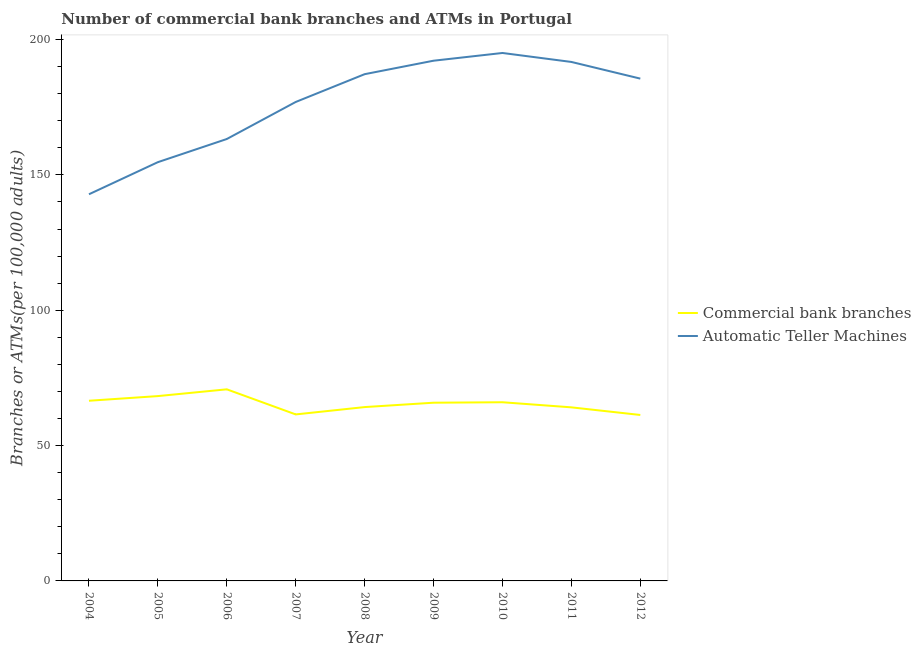Does the line corresponding to number of commercal bank branches intersect with the line corresponding to number of atms?
Ensure brevity in your answer.  No. Is the number of lines equal to the number of legend labels?
Offer a terse response. Yes. What is the number of atms in 2009?
Your answer should be very brief. 192.19. Across all years, what is the maximum number of atms?
Give a very brief answer. 195.04. Across all years, what is the minimum number of atms?
Provide a short and direct response. 142.84. What is the total number of atms in the graph?
Offer a very short reply. 1589.49. What is the difference between the number of commercal bank branches in 2005 and that in 2010?
Ensure brevity in your answer.  2.27. What is the difference between the number of atms in 2008 and the number of commercal bank branches in 2007?
Provide a succinct answer. 125.7. What is the average number of commercal bank branches per year?
Your answer should be very brief. 65.41. In the year 2011, what is the difference between the number of commercal bank branches and number of atms?
Your answer should be very brief. -127.6. In how many years, is the number of commercal bank branches greater than 130?
Make the answer very short. 0. What is the ratio of the number of atms in 2005 to that in 2006?
Make the answer very short. 0.95. What is the difference between the highest and the second highest number of commercal bank branches?
Make the answer very short. 2.5. What is the difference between the highest and the lowest number of commercal bank branches?
Keep it short and to the point. 9.48. In how many years, is the number of atms greater than the average number of atms taken over all years?
Provide a short and direct response. 6. Does the number of commercal bank branches monotonically increase over the years?
Keep it short and to the point. No. Is the number of atms strictly less than the number of commercal bank branches over the years?
Your answer should be compact. No. How many years are there in the graph?
Provide a succinct answer. 9. Are the values on the major ticks of Y-axis written in scientific E-notation?
Make the answer very short. No. Does the graph contain any zero values?
Provide a short and direct response. No. Does the graph contain grids?
Provide a succinct answer. No. Where does the legend appear in the graph?
Give a very brief answer. Center right. How many legend labels are there?
Provide a short and direct response. 2. What is the title of the graph?
Ensure brevity in your answer.  Number of commercial bank branches and ATMs in Portugal. Does "Lower secondary rate" appear as one of the legend labels in the graph?
Your response must be concise. No. What is the label or title of the Y-axis?
Ensure brevity in your answer.  Branches or ATMs(per 100,0 adults). What is the Branches or ATMs(per 100,000 adults) in Commercial bank branches in 2004?
Ensure brevity in your answer.  66.56. What is the Branches or ATMs(per 100,000 adults) in Automatic Teller Machines in 2004?
Your response must be concise. 142.84. What is the Branches or ATMs(per 100,000 adults) of Commercial bank branches in 2005?
Your answer should be very brief. 68.28. What is the Branches or ATMs(per 100,000 adults) of Automatic Teller Machines in 2005?
Give a very brief answer. 154.71. What is the Branches or ATMs(per 100,000 adults) in Commercial bank branches in 2006?
Keep it short and to the point. 70.78. What is the Branches or ATMs(per 100,000 adults) of Automatic Teller Machines in 2006?
Make the answer very short. 163.26. What is the Branches or ATMs(per 100,000 adults) in Commercial bank branches in 2007?
Give a very brief answer. 61.51. What is the Branches or ATMs(per 100,000 adults) of Automatic Teller Machines in 2007?
Make the answer very short. 176.94. What is the Branches or ATMs(per 100,000 adults) of Commercial bank branches in 2008?
Keep it short and to the point. 64.22. What is the Branches or ATMs(per 100,000 adults) of Automatic Teller Machines in 2008?
Keep it short and to the point. 187.21. What is the Branches or ATMs(per 100,000 adults) in Commercial bank branches in 2009?
Provide a short and direct response. 65.84. What is the Branches or ATMs(per 100,000 adults) of Automatic Teller Machines in 2009?
Your answer should be compact. 192.19. What is the Branches or ATMs(per 100,000 adults) of Commercial bank branches in 2010?
Provide a succinct answer. 66.01. What is the Branches or ATMs(per 100,000 adults) in Automatic Teller Machines in 2010?
Your answer should be compact. 195.04. What is the Branches or ATMs(per 100,000 adults) of Commercial bank branches in 2011?
Ensure brevity in your answer.  64.13. What is the Branches or ATMs(per 100,000 adults) in Automatic Teller Machines in 2011?
Your answer should be very brief. 191.73. What is the Branches or ATMs(per 100,000 adults) in Commercial bank branches in 2012?
Offer a very short reply. 61.31. What is the Branches or ATMs(per 100,000 adults) of Automatic Teller Machines in 2012?
Your answer should be compact. 185.57. Across all years, what is the maximum Branches or ATMs(per 100,000 adults) in Commercial bank branches?
Provide a short and direct response. 70.78. Across all years, what is the maximum Branches or ATMs(per 100,000 adults) in Automatic Teller Machines?
Give a very brief answer. 195.04. Across all years, what is the minimum Branches or ATMs(per 100,000 adults) in Commercial bank branches?
Give a very brief answer. 61.31. Across all years, what is the minimum Branches or ATMs(per 100,000 adults) in Automatic Teller Machines?
Offer a terse response. 142.84. What is the total Branches or ATMs(per 100,000 adults) of Commercial bank branches in the graph?
Keep it short and to the point. 588.65. What is the total Branches or ATMs(per 100,000 adults) of Automatic Teller Machines in the graph?
Ensure brevity in your answer.  1589.49. What is the difference between the Branches or ATMs(per 100,000 adults) in Commercial bank branches in 2004 and that in 2005?
Your answer should be compact. -1.72. What is the difference between the Branches or ATMs(per 100,000 adults) of Automatic Teller Machines in 2004 and that in 2005?
Keep it short and to the point. -11.86. What is the difference between the Branches or ATMs(per 100,000 adults) in Commercial bank branches in 2004 and that in 2006?
Ensure brevity in your answer.  -4.22. What is the difference between the Branches or ATMs(per 100,000 adults) in Automatic Teller Machines in 2004 and that in 2006?
Offer a very short reply. -20.42. What is the difference between the Branches or ATMs(per 100,000 adults) in Commercial bank branches in 2004 and that in 2007?
Offer a very short reply. 5.05. What is the difference between the Branches or ATMs(per 100,000 adults) of Automatic Teller Machines in 2004 and that in 2007?
Give a very brief answer. -34.1. What is the difference between the Branches or ATMs(per 100,000 adults) in Commercial bank branches in 2004 and that in 2008?
Your answer should be compact. 2.34. What is the difference between the Branches or ATMs(per 100,000 adults) of Automatic Teller Machines in 2004 and that in 2008?
Your answer should be very brief. -44.37. What is the difference between the Branches or ATMs(per 100,000 adults) of Commercial bank branches in 2004 and that in 2009?
Ensure brevity in your answer.  0.72. What is the difference between the Branches or ATMs(per 100,000 adults) in Automatic Teller Machines in 2004 and that in 2009?
Provide a succinct answer. -49.34. What is the difference between the Branches or ATMs(per 100,000 adults) of Commercial bank branches in 2004 and that in 2010?
Provide a short and direct response. 0.55. What is the difference between the Branches or ATMs(per 100,000 adults) in Automatic Teller Machines in 2004 and that in 2010?
Your response must be concise. -52.2. What is the difference between the Branches or ATMs(per 100,000 adults) in Commercial bank branches in 2004 and that in 2011?
Keep it short and to the point. 2.44. What is the difference between the Branches or ATMs(per 100,000 adults) of Automatic Teller Machines in 2004 and that in 2011?
Your answer should be compact. -48.89. What is the difference between the Branches or ATMs(per 100,000 adults) in Commercial bank branches in 2004 and that in 2012?
Your answer should be very brief. 5.25. What is the difference between the Branches or ATMs(per 100,000 adults) of Automatic Teller Machines in 2004 and that in 2012?
Provide a succinct answer. -42.73. What is the difference between the Branches or ATMs(per 100,000 adults) in Commercial bank branches in 2005 and that in 2006?
Ensure brevity in your answer.  -2.5. What is the difference between the Branches or ATMs(per 100,000 adults) of Automatic Teller Machines in 2005 and that in 2006?
Make the answer very short. -8.55. What is the difference between the Branches or ATMs(per 100,000 adults) in Commercial bank branches in 2005 and that in 2007?
Keep it short and to the point. 6.77. What is the difference between the Branches or ATMs(per 100,000 adults) of Automatic Teller Machines in 2005 and that in 2007?
Provide a succinct answer. -22.23. What is the difference between the Branches or ATMs(per 100,000 adults) of Commercial bank branches in 2005 and that in 2008?
Make the answer very short. 4.06. What is the difference between the Branches or ATMs(per 100,000 adults) in Automatic Teller Machines in 2005 and that in 2008?
Offer a very short reply. -32.5. What is the difference between the Branches or ATMs(per 100,000 adults) in Commercial bank branches in 2005 and that in 2009?
Provide a succinct answer. 2.44. What is the difference between the Branches or ATMs(per 100,000 adults) of Automatic Teller Machines in 2005 and that in 2009?
Offer a very short reply. -37.48. What is the difference between the Branches or ATMs(per 100,000 adults) in Commercial bank branches in 2005 and that in 2010?
Your answer should be compact. 2.27. What is the difference between the Branches or ATMs(per 100,000 adults) of Automatic Teller Machines in 2005 and that in 2010?
Your answer should be compact. -40.34. What is the difference between the Branches or ATMs(per 100,000 adults) of Commercial bank branches in 2005 and that in 2011?
Provide a succinct answer. 4.16. What is the difference between the Branches or ATMs(per 100,000 adults) in Automatic Teller Machines in 2005 and that in 2011?
Offer a terse response. -37.02. What is the difference between the Branches or ATMs(per 100,000 adults) of Commercial bank branches in 2005 and that in 2012?
Your answer should be very brief. 6.97. What is the difference between the Branches or ATMs(per 100,000 adults) of Automatic Teller Machines in 2005 and that in 2012?
Offer a very short reply. -30.86. What is the difference between the Branches or ATMs(per 100,000 adults) of Commercial bank branches in 2006 and that in 2007?
Ensure brevity in your answer.  9.27. What is the difference between the Branches or ATMs(per 100,000 adults) of Automatic Teller Machines in 2006 and that in 2007?
Keep it short and to the point. -13.68. What is the difference between the Branches or ATMs(per 100,000 adults) in Commercial bank branches in 2006 and that in 2008?
Your answer should be compact. 6.56. What is the difference between the Branches or ATMs(per 100,000 adults) in Automatic Teller Machines in 2006 and that in 2008?
Give a very brief answer. -23.95. What is the difference between the Branches or ATMs(per 100,000 adults) of Commercial bank branches in 2006 and that in 2009?
Provide a short and direct response. 4.94. What is the difference between the Branches or ATMs(per 100,000 adults) of Automatic Teller Machines in 2006 and that in 2009?
Give a very brief answer. -28.93. What is the difference between the Branches or ATMs(per 100,000 adults) of Commercial bank branches in 2006 and that in 2010?
Offer a terse response. 4.77. What is the difference between the Branches or ATMs(per 100,000 adults) of Automatic Teller Machines in 2006 and that in 2010?
Ensure brevity in your answer.  -31.78. What is the difference between the Branches or ATMs(per 100,000 adults) of Commercial bank branches in 2006 and that in 2011?
Provide a succinct answer. 6.66. What is the difference between the Branches or ATMs(per 100,000 adults) of Automatic Teller Machines in 2006 and that in 2011?
Make the answer very short. -28.47. What is the difference between the Branches or ATMs(per 100,000 adults) of Commercial bank branches in 2006 and that in 2012?
Keep it short and to the point. 9.48. What is the difference between the Branches or ATMs(per 100,000 adults) in Automatic Teller Machines in 2006 and that in 2012?
Offer a terse response. -22.31. What is the difference between the Branches or ATMs(per 100,000 adults) in Commercial bank branches in 2007 and that in 2008?
Ensure brevity in your answer.  -2.71. What is the difference between the Branches or ATMs(per 100,000 adults) in Automatic Teller Machines in 2007 and that in 2008?
Offer a terse response. -10.27. What is the difference between the Branches or ATMs(per 100,000 adults) in Commercial bank branches in 2007 and that in 2009?
Provide a short and direct response. -4.33. What is the difference between the Branches or ATMs(per 100,000 adults) of Automatic Teller Machines in 2007 and that in 2009?
Your answer should be compact. -15.24. What is the difference between the Branches or ATMs(per 100,000 adults) in Commercial bank branches in 2007 and that in 2010?
Ensure brevity in your answer.  -4.5. What is the difference between the Branches or ATMs(per 100,000 adults) of Automatic Teller Machines in 2007 and that in 2010?
Offer a very short reply. -18.1. What is the difference between the Branches or ATMs(per 100,000 adults) in Commercial bank branches in 2007 and that in 2011?
Give a very brief answer. -2.61. What is the difference between the Branches or ATMs(per 100,000 adults) of Automatic Teller Machines in 2007 and that in 2011?
Your answer should be compact. -14.79. What is the difference between the Branches or ATMs(per 100,000 adults) in Commercial bank branches in 2007 and that in 2012?
Ensure brevity in your answer.  0.2. What is the difference between the Branches or ATMs(per 100,000 adults) in Automatic Teller Machines in 2007 and that in 2012?
Provide a succinct answer. -8.63. What is the difference between the Branches or ATMs(per 100,000 adults) in Commercial bank branches in 2008 and that in 2009?
Your answer should be compact. -1.62. What is the difference between the Branches or ATMs(per 100,000 adults) of Automatic Teller Machines in 2008 and that in 2009?
Provide a short and direct response. -4.98. What is the difference between the Branches or ATMs(per 100,000 adults) of Commercial bank branches in 2008 and that in 2010?
Keep it short and to the point. -1.79. What is the difference between the Branches or ATMs(per 100,000 adults) in Automatic Teller Machines in 2008 and that in 2010?
Provide a succinct answer. -7.83. What is the difference between the Branches or ATMs(per 100,000 adults) of Commercial bank branches in 2008 and that in 2011?
Ensure brevity in your answer.  0.1. What is the difference between the Branches or ATMs(per 100,000 adults) in Automatic Teller Machines in 2008 and that in 2011?
Provide a short and direct response. -4.52. What is the difference between the Branches or ATMs(per 100,000 adults) in Commercial bank branches in 2008 and that in 2012?
Give a very brief answer. 2.91. What is the difference between the Branches or ATMs(per 100,000 adults) of Automatic Teller Machines in 2008 and that in 2012?
Give a very brief answer. 1.64. What is the difference between the Branches or ATMs(per 100,000 adults) in Commercial bank branches in 2009 and that in 2010?
Offer a terse response. -0.17. What is the difference between the Branches or ATMs(per 100,000 adults) of Automatic Teller Machines in 2009 and that in 2010?
Provide a short and direct response. -2.86. What is the difference between the Branches or ATMs(per 100,000 adults) in Commercial bank branches in 2009 and that in 2011?
Offer a terse response. 1.72. What is the difference between the Branches or ATMs(per 100,000 adults) in Automatic Teller Machines in 2009 and that in 2011?
Your answer should be very brief. 0.46. What is the difference between the Branches or ATMs(per 100,000 adults) in Commercial bank branches in 2009 and that in 2012?
Your answer should be compact. 4.53. What is the difference between the Branches or ATMs(per 100,000 adults) in Automatic Teller Machines in 2009 and that in 2012?
Make the answer very short. 6.62. What is the difference between the Branches or ATMs(per 100,000 adults) of Commercial bank branches in 2010 and that in 2011?
Make the answer very short. 1.88. What is the difference between the Branches or ATMs(per 100,000 adults) of Automatic Teller Machines in 2010 and that in 2011?
Ensure brevity in your answer.  3.31. What is the difference between the Branches or ATMs(per 100,000 adults) in Commercial bank branches in 2010 and that in 2012?
Offer a very short reply. 4.7. What is the difference between the Branches or ATMs(per 100,000 adults) in Automatic Teller Machines in 2010 and that in 2012?
Your response must be concise. 9.47. What is the difference between the Branches or ATMs(per 100,000 adults) in Commercial bank branches in 2011 and that in 2012?
Your response must be concise. 2.82. What is the difference between the Branches or ATMs(per 100,000 adults) of Automatic Teller Machines in 2011 and that in 2012?
Provide a succinct answer. 6.16. What is the difference between the Branches or ATMs(per 100,000 adults) of Commercial bank branches in 2004 and the Branches or ATMs(per 100,000 adults) of Automatic Teller Machines in 2005?
Give a very brief answer. -88.15. What is the difference between the Branches or ATMs(per 100,000 adults) in Commercial bank branches in 2004 and the Branches or ATMs(per 100,000 adults) in Automatic Teller Machines in 2006?
Your answer should be compact. -96.7. What is the difference between the Branches or ATMs(per 100,000 adults) in Commercial bank branches in 2004 and the Branches or ATMs(per 100,000 adults) in Automatic Teller Machines in 2007?
Your response must be concise. -110.38. What is the difference between the Branches or ATMs(per 100,000 adults) of Commercial bank branches in 2004 and the Branches or ATMs(per 100,000 adults) of Automatic Teller Machines in 2008?
Give a very brief answer. -120.65. What is the difference between the Branches or ATMs(per 100,000 adults) in Commercial bank branches in 2004 and the Branches or ATMs(per 100,000 adults) in Automatic Teller Machines in 2009?
Provide a succinct answer. -125.62. What is the difference between the Branches or ATMs(per 100,000 adults) of Commercial bank branches in 2004 and the Branches or ATMs(per 100,000 adults) of Automatic Teller Machines in 2010?
Your response must be concise. -128.48. What is the difference between the Branches or ATMs(per 100,000 adults) of Commercial bank branches in 2004 and the Branches or ATMs(per 100,000 adults) of Automatic Teller Machines in 2011?
Offer a terse response. -125.17. What is the difference between the Branches or ATMs(per 100,000 adults) of Commercial bank branches in 2004 and the Branches or ATMs(per 100,000 adults) of Automatic Teller Machines in 2012?
Make the answer very short. -119.01. What is the difference between the Branches or ATMs(per 100,000 adults) in Commercial bank branches in 2005 and the Branches or ATMs(per 100,000 adults) in Automatic Teller Machines in 2006?
Your response must be concise. -94.97. What is the difference between the Branches or ATMs(per 100,000 adults) of Commercial bank branches in 2005 and the Branches or ATMs(per 100,000 adults) of Automatic Teller Machines in 2007?
Provide a succinct answer. -108.66. What is the difference between the Branches or ATMs(per 100,000 adults) in Commercial bank branches in 2005 and the Branches or ATMs(per 100,000 adults) in Automatic Teller Machines in 2008?
Keep it short and to the point. -118.93. What is the difference between the Branches or ATMs(per 100,000 adults) in Commercial bank branches in 2005 and the Branches or ATMs(per 100,000 adults) in Automatic Teller Machines in 2009?
Provide a short and direct response. -123.9. What is the difference between the Branches or ATMs(per 100,000 adults) of Commercial bank branches in 2005 and the Branches or ATMs(per 100,000 adults) of Automatic Teller Machines in 2010?
Make the answer very short. -126.76. What is the difference between the Branches or ATMs(per 100,000 adults) of Commercial bank branches in 2005 and the Branches or ATMs(per 100,000 adults) of Automatic Teller Machines in 2011?
Your answer should be compact. -123.44. What is the difference between the Branches or ATMs(per 100,000 adults) of Commercial bank branches in 2005 and the Branches or ATMs(per 100,000 adults) of Automatic Teller Machines in 2012?
Your answer should be very brief. -117.29. What is the difference between the Branches or ATMs(per 100,000 adults) in Commercial bank branches in 2006 and the Branches or ATMs(per 100,000 adults) in Automatic Teller Machines in 2007?
Offer a terse response. -106.16. What is the difference between the Branches or ATMs(per 100,000 adults) of Commercial bank branches in 2006 and the Branches or ATMs(per 100,000 adults) of Automatic Teller Machines in 2008?
Provide a succinct answer. -116.43. What is the difference between the Branches or ATMs(per 100,000 adults) of Commercial bank branches in 2006 and the Branches or ATMs(per 100,000 adults) of Automatic Teller Machines in 2009?
Make the answer very short. -121.4. What is the difference between the Branches or ATMs(per 100,000 adults) of Commercial bank branches in 2006 and the Branches or ATMs(per 100,000 adults) of Automatic Teller Machines in 2010?
Provide a short and direct response. -124.26. What is the difference between the Branches or ATMs(per 100,000 adults) in Commercial bank branches in 2006 and the Branches or ATMs(per 100,000 adults) in Automatic Teller Machines in 2011?
Your answer should be very brief. -120.94. What is the difference between the Branches or ATMs(per 100,000 adults) of Commercial bank branches in 2006 and the Branches or ATMs(per 100,000 adults) of Automatic Teller Machines in 2012?
Provide a short and direct response. -114.79. What is the difference between the Branches or ATMs(per 100,000 adults) in Commercial bank branches in 2007 and the Branches or ATMs(per 100,000 adults) in Automatic Teller Machines in 2008?
Ensure brevity in your answer.  -125.7. What is the difference between the Branches or ATMs(per 100,000 adults) of Commercial bank branches in 2007 and the Branches or ATMs(per 100,000 adults) of Automatic Teller Machines in 2009?
Give a very brief answer. -130.68. What is the difference between the Branches or ATMs(per 100,000 adults) in Commercial bank branches in 2007 and the Branches or ATMs(per 100,000 adults) in Automatic Teller Machines in 2010?
Make the answer very short. -133.53. What is the difference between the Branches or ATMs(per 100,000 adults) in Commercial bank branches in 2007 and the Branches or ATMs(per 100,000 adults) in Automatic Teller Machines in 2011?
Offer a very short reply. -130.22. What is the difference between the Branches or ATMs(per 100,000 adults) in Commercial bank branches in 2007 and the Branches or ATMs(per 100,000 adults) in Automatic Teller Machines in 2012?
Provide a short and direct response. -124.06. What is the difference between the Branches or ATMs(per 100,000 adults) in Commercial bank branches in 2008 and the Branches or ATMs(per 100,000 adults) in Automatic Teller Machines in 2009?
Offer a terse response. -127.97. What is the difference between the Branches or ATMs(per 100,000 adults) of Commercial bank branches in 2008 and the Branches or ATMs(per 100,000 adults) of Automatic Teller Machines in 2010?
Ensure brevity in your answer.  -130.82. What is the difference between the Branches or ATMs(per 100,000 adults) in Commercial bank branches in 2008 and the Branches or ATMs(per 100,000 adults) in Automatic Teller Machines in 2011?
Offer a very short reply. -127.51. What is the difference between the Branches or ATMs(per 100,000 adults) of Commercial bank branches in 2008 and the Branches or ATMs(per 100,000 adults) of Automatic Teller Machines in 2012?
Provide a succinct answer. -121.35. What is the difference between the Branches or ATMs(per 100,000 adults) of Commercial bank branches in 2009 and the Branches or ATMs(per 100,000 adults) of Automatic Teller Machines in 2010?
Your answer should be very brief. -129.2. What is the difference between the Branches or ATMs(per 100,000 adults) in Commercial bank branches in 2009 and the Branches or ATMs(per 100,000 adults) in Automatic Teller Machines in 2011?
Make the answer very short. -125.89. What is the difference between the Branches or ATMs(per 100,000 adults) in Commercial bank branches in 2009 and the Branches or ATMs(per 100,000 adults) in Automatic Teller Machines in 2012?
Ensure brevity in your answer.  -119.73. What is the difference between the Branches or ATMs(per 100,000 adults) in Commercial bank branches in 2010 and the Branches or ATMs(per 100,000 adults) in Automatic Teller Machines in 2011?
Offer a very short reply. -125.72. What is the difference between the Branches or ATMs(per 100,000 adults) in Commercial bank branches in 2010 and the Branches or ATMs(per 100,000 adults) in Automatic Teller Machines in 2012?
Your answer should be very brief. -119.56. What is the difference between the Branches or ATMs(per 100,000 adults) of Commercial bank branches in 2011 and the Branches or ATMs(per 100,000 adults) of Automatic Teller Machines in 2012?
Provide a succinct answer. -121.45. What is the average Branches or ATMs(per 100,000 adults) in Commercial bank branches per year?
Your response must be concise. 65.41. What is the average Branches or ATMs(per 100,000 adults) of Automatic Teller Machines per year?
Keep it short and to the point. 176.61. In the year 2004, what is the difference between the Branches or ATMs(per 100,000 adults) in Commercial bank branches and Branches or ATMs(per 100,000 adults) in Automatic Teller Machines?
Provide a succinct answer. -76.28. In the year 2005, what is the difference between the Branches or ATMs(per 100,000 adults) in Commercial bank branches and Branches or ATMs(per 100,000 adults) in Automatic Teller Machines?
Provide a short and direct response. -86.42. In the year 2006, what is the difference between the Branches or ATMs(per 100,000 adults) of Commercial bank branches and Branches or ATMs(per 100,000 adults) of Automatic Teller Machines?
Provide a succinct answer. -92.47. In the year 2007, what is the difference between the Branches or ATMs(per 100,000 adults) in Commercial bank branches and Branches or ATMs(per 100,000 adults) in Automatic Teller Machines?
Offer a very short reply. -115.43. In the year 2008, what is the difference between the Branches or ATMs(per 100,000 adults) of Commercial bank branches and Branches or ATMs(per 100,000 adults) of Automatic Teller Machines?
Provide a short and direct response. -122.99. In the year 2009, what is the difference between the Branches or ATMs(per 100,000 adults) of Commercial bank branches and Branches or ATMs(per 100,000 adults) of Automatic Teller Machines?
Your answer should be very brief. -126.35. In the year 2010, what is the difference between the Branches or ATMs(per 100,000 adults) of Commercial bank branches and Branches or ATMs(per 100,000 adults) of Automatic Teller Machines?
Keep it short and to the point. -129.03. In the year 2011, what is the difference between the Branches or ATMs(per 100,000 adults) of Commercial bank branches and Branches or ATMs(per 100,000 adults) of Automatic Teller Machines?
Your response must be concise. -127.6. In the year 2012, what is the difference between the Branches or ATMs(per 100,000 adults) in Commercial bank branches and Branches or ATMs(per 100,000 adults) in Automatic Teller Machines?
Ensure brevity in your answer.  -124.26. What is the ratio of the Branches or ATMs(per 100,000 adults) in Commercial bank branches in 2004 to that in 2005?
Make the answer very short. 0.97. What is the ratio of the Branches or ATMs(per 100,000 adults) of Automatic Teller Machines in 2004 to that in 2005?
Your answer should be compact. 0.92. What is the ratio of the Branches or ATMs(per 100,000 adults) in Commercial bank branches in 2004 to that in 2006?
Give a very brief answer. 0.94. What is the ratio of the Branches or ATMs(per 100,000 adults) in Automatic Teller Machines in 2004 to that in 2006?
Provide a succinct answer. 0.88. What is the ratio of the Branches or ATMs(per 100,000 adults) of Commercial bank branches in 2004 to that in 2007?
Your answer should be compact. 1.08. What is the ratio of the Branches or ATMs(per 100,000 adults) of Automatic Teller Machines in 2004 to that in 2007?
Ensure brevity in your answer.  0.81. What is the ratio of the Branches or ATMs(per 100,000 adults) in Commercial bank branches in 2004 to that in 2008?
Your answer should be very brief. 1.04. What is the ratio of the Branches or ATMs(per 100,000 adults) of Automatic Teller Machines in 2004 to that in 2008?
Offer a terse response. 0.76. What is the ratio of the Branches or ATMs(per 100,000 adults) of Commercial bank branches in 2004 to that in 2009?
Keep it short and to the point. 1.01. What is the ratio of the Branches or ATMs(per 100,000 adults) in Automatic Teller Machines in 2004 to that in 2009?
Give a very brief answer. 0.74. What is the ratio of the Branches or ATMs(per 100,000 adults) of Commercial bank branches in 2004 to that in 2010?
Give a very brief answer. 1.01. What is the ratio of the Branches or ATMs(per 100,000 adults) in Automatic Teller Machines in 2004 to that in 2010?
Make the answer very short. 0.73. What is the ratio of the Branches or ATMs(per 100,000 adults) in Commercial bank branches in 2004 to that in 2011?
Your answer should be very brief. 1.04. What is the ratio of the Branches or ATMs(per 100,000 adults) of Automatic Teller Machines in 2004 to that in 2011?
Provide a succinct answer. 0.74. What is the ratio of the Branches or ATMs(per 100,000 adults) in Commercial bank branches in 2004 to that in 2012?
Provide a succinct answer. 1.09. What is the ratio of the Branches or ATMs(per 100,000 adults) in Automatic Teller Machines in 2004 to that in 2012?
Keep it short and to the point. 0.77. What is the ratio of the Branches or ATMs(per 100,000 adults) of Commercial bank branches in 2005 to that in 2006?
Keep it short and to the point. 0.96. What is the ratio of the Branches or ATMs(per 100,000 adults) in Automatic Teller Machines in 2005 to that in 2006?
Make the answer very short. 0.95. What is the ratio of the Branches or ATMs(per 100,000 adults) in Commercial bank branches in 2005 to that in 2007?
Your response must be concise. 1.11. What is the ratio of the Branches or ATMs(per 100,000 adults) in Automatic Teller Machines in 2005 to that in 2007?
Your answer should be compact. 0.87. What is the ratio of the Branches or ATMs(per 100,000 adults) in Commercial bank branches in 2005 to that in 2008?
Your response must be concise. 1.06. What is the ratio of the Branches or ATMs(per 100,000 adults) in Automatic Teller Machines in 2005 to that in 2008?
Your response must be concise. 0.83. What is the ratio of the Branches or ATMs(per 100,000 adults) in Commercial bank branches in 2005 to that in 2009?
Give a very brief answer. 1.04. What is the ratio of the Branches or ATMs(per 100,000 adults) in Automatic Teller Machines in 2005 to that in 2009?
Your response must be concise. 0.81. What is the ratio of the Branches or ATMs(per 100,000 adults) in Commercial bank branches in 2005 to that in 2010?
Your response must be concise. 1.03. What is the ratio of the Branches or ATMs(per 100,000 adults) of Automatic Teller Machines in 2005 to that in 2010?
Your answer should be very brief. 0.79. What is the ratio of the Branches or ATMs(per 100,000 adults) of Commercial bank branches in 2005 to that in 2011?
Your answer should be very brief. 1.06. What is the ratio of the Branches or ATMs(per 100,000 adults) in Automatic Teller Machines in 2005 to that in 2011?
Provide a short and direct response. 0.81. What is the ratio of the Branches or ATMs(per 100,000 adults) in Commercial bank branches in 2005 to that in 2012?
Your answer should be very brief. 1.11. What is the ratio of the Branches or ATMs(per 100,000 adults) of Automatic Teller Machines in 2005 to that in 2012?
Offer a terse response. 0.83. What is the ratio of the Branches or ATMs(per 100,000 adults) of Commercial bank branches in 2006 to that in 2007?
Make the answer very short. 1.15. What is the ratio of the Branches or ATMs(per 100,000 adults) of Automatic Teller Machines in 2006 to that in 2007?
Ensure brevity in your answer.  0.92. What is the ratio of the Branches or ATMs(per 100,000 adults) in Commercial bank branches in 2006 to that in 2008?
Your answer should be compact. 1.1. What is the ratio of the Branches or ATMs(per 100,000 adults) of Automatic Teller Machines in 2006 to that in 2008?
Give a very brief answer. 0.87. What is the ratio of the Branches or ATMs(per 100,000 adults) of Commercial bank branches in 2006 to that in 2009?
Your response must be concise. 1.08. What is the ratio of the Branches or ATMs(per 100,000 adults) of Automatic Teller Machines in 2006 to that in 2009?
Your response must be concise. 0.85. What is the ratio of the Branches or ATMs(per 100,000 adults) of Commercial bank branches in 2006 to that in 2010?
Give a very brief answer. 1.07. What is the ratio of the Branches or ATMs(per 100,000 adults) of Automatic Teller Machines in 2006 to that in 2010?
Give a very brief answer. 0.84. What is the ratio of the Branches or ATMs(per 100,000 adults) in Commercial bank branches in 2006 to that in 2011?
Your answer should be very brief. 1.1. What is the ratio of the Branches or ATMs(per 100,000 adults) of Automatic Teller Machines in 2006 to that in 2011?
Your answer should be very brief. 0.85. What is the ratio of the Branches or ATMs(per 100,000 adults) of Commercial bank branches in 2006 to that in 2012?
Give a very brief answer. 1.15. What is the ratio of the Branches or ATMs(per 100,000 adults) in Automatic Teller Machines in 2006 to that in 2012?
Provide a short and direct response. 0.88. What is the ratio of the Branches or ATMs(per 100,000 adults) in Commercial bank branches in 2007 to that in 2008?
Offer a terse response. 0.96. What is the ratio of the Branches or ATMs(per 100,000 adults) of Automatic Teller Machines in 2007 to that in 2008?
Give a very brief answer. 0.95. What is the ratio of the Branches or ATMs(per 100,000 adults) in Commercial bank branches in 2007 to that in 2009?
Your response must be concise. 0.93. What is the ratio of the Branches or ATMs(per 100,000 adults) of Automatic Teller Machines in 2007 to that in 2009?
Provide a succinct answer. 0.92. What is the ratio of the Branches or ATMs(per 100,000 adults) in Commercial bank branches in 2007 to that in 2010?
Your answer should be very brief. 0.93. What is the ratio of the Branches or ATMs(per 100,000 adults) of Automatic Teller Machines in 2007 to that in 2010?
Make the answer very short. 0.91. What is the ratio of the Branches or ATMs(per 100,000 adults) of Commercial bank branches in 2007 to that in 2011?
Ensure brevity in your answer.  0.96. What is the ratio of the Branches or ATMs(per 100,000 adults) of Automatic Teller Machines in 2007 to that in 2011?
Keep it short and to the point. 0.92. What is the ratio of the Branches or ATMs(per 100,000 adults) of Automatic Teller Machines in 2007 to that in 2012?
Provide a succinct answer. 0.95. What is the ratio of the Branches or ATMs(per 100,000 adults) of Commercial bank branches in 2008 to that in 2009?
Keep it short and to the point. 0.98. What is the ratio of the Branches or ATMs(per 100,000 adults) in Automatic Teller Machines in 2008 to that in 2009?
Offer a terse response. 0.97. What is the ratio of the Branches or ATMs(per 100,000 adults) in Commercial bank branches in 2008 to that in 2010?
Provide a short and direct response. 0.97. What is the ratio of the Branches or ATMs(per 100,000 adults) in Automatic Teller Machines in 2008 to that in 2010?
Offer a terse response. 0.96. What is the ratio of the Branches or ATMs(per 100,000 adults) in Commercial bank branches in 2008 to that in 2011?
Make the answer very short. 1. What is the ratio of the Branches or ATMs(per 100,000 adults) of Automatic Teller Machines in 2008 to that in 2011?
Your answer should be compact. 0.98. What is the ratio of the Branches or ATMs(per 100,000 adults) of Commercial bank branches in 2008 to that in 2012?
Provide a short and direct response. 1.05. What is the ratio of the Branches or ATMs(per 100,000 adults) in Automatic Teller Machines in 2008 to that in 2012?
Give a very brief answer. 1.01. What is the ratio of the Branches or ATMs(per 100,000 adults) of Automatic Teller Machines in 2009 to that in 2010?
Give a very brief answer. 0.99. What is the ratio of the Branches or ATMs(per 100,000 adults) of Commercial bank branches in 2009 to that in 2011?
Keep it short and to the point. 1.03. What is the ratio of the Branches or ATMs(per 100,000 adults) in Automatic Teller Machines in 2009 to that in 2011?
Your response must be concise. 1. What is the ratio of the Branches or ATMs(per 100,000 adults) in Commercial bank branches in 2009 to that in 2012?
Ensure brevity in your answer.  1.07. What is the ratio of the Branches or ATMs(per 100,000 adults) in Automatic Teller Machines in 2009 to that in 2012?
Provide a short and direct response. 1.04. What is the ratio of the Branches or ATMs(per 100,000 adults) of Commercial bank branches in 2010 to that in 2011?
Give a very brief answer. 1.03. What is the ratio of the Branches or ATMs(per 100,000 adults) of Automatic Teller Machines in 2010 to that in 2011?
Ensure brevity in your answer.  1.02. What is the ratio of the Branches or ATMs(per 100,000 adults) of Commercial bank branches in 2010 to that in 2012?
Ensure brevity in your answer.  1.08. What is the ratio of the Branches or ATMs(per 100,000 adults) in Automatic Teller Machines in 2010 to that in 2012?
Provide a succinct answer. 1.05. What is the ratio of the Branches or ATMs(per 100,000 adults) of Commercial bank branches in 2011 to that in 2012?
Ensure brevity in your answer.  1.05. What is the ratio of the Branches or ATMs(per 100,000 adults) in Automatic Teller Machines in 2011 to that in 2012?
Ensure brevity in your answer.  1.03. What is the difference between the highest and the second highest Branches or ATMs(per 100,000 adults) of Commercial bank branches?
Keep it short and to the point. 2.5. What is the difference between the highest and the second highest Branches or ATMs(per 100,000 adults) of Automatic Teller Machines?
Make the answer very short. 2.86. What is the difference between the highest and the lowest Branches or ATMs(per 100,000 adults) of Commercial bank branches?
Make the answer very short. 9.48. What is the difference between the highest and the lowest Branches or ATMs(per 100,000 adults) in Automatic Teller Machines?
Provide a short and direct response. 52.2. 